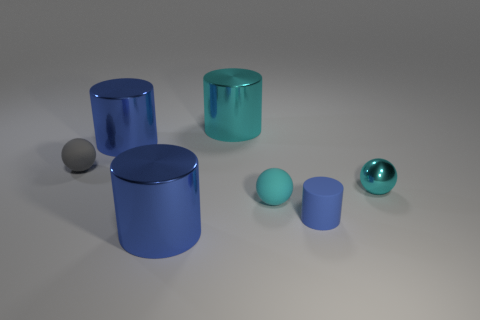How many blue cylinders must be subtracted to get 1 blue cylinders? 2 Subtract all purple spheres. How many blue cylinders are left? 3 Add 3 gray matte blocks. How many objects exist? 10 Subtract all cylinders. How many objects are left? 3 Add 3 big matte cubes. How many big matte cubes exist? 3 Subtract 1 cyan cylinders. How many objects are left? 6 Subtract all big blue cylinders. Subtract all tiny shiny objects. How many objects are left? 4 Add 7 big cyan cylinders. How many big cyan cylinders are left? 8 